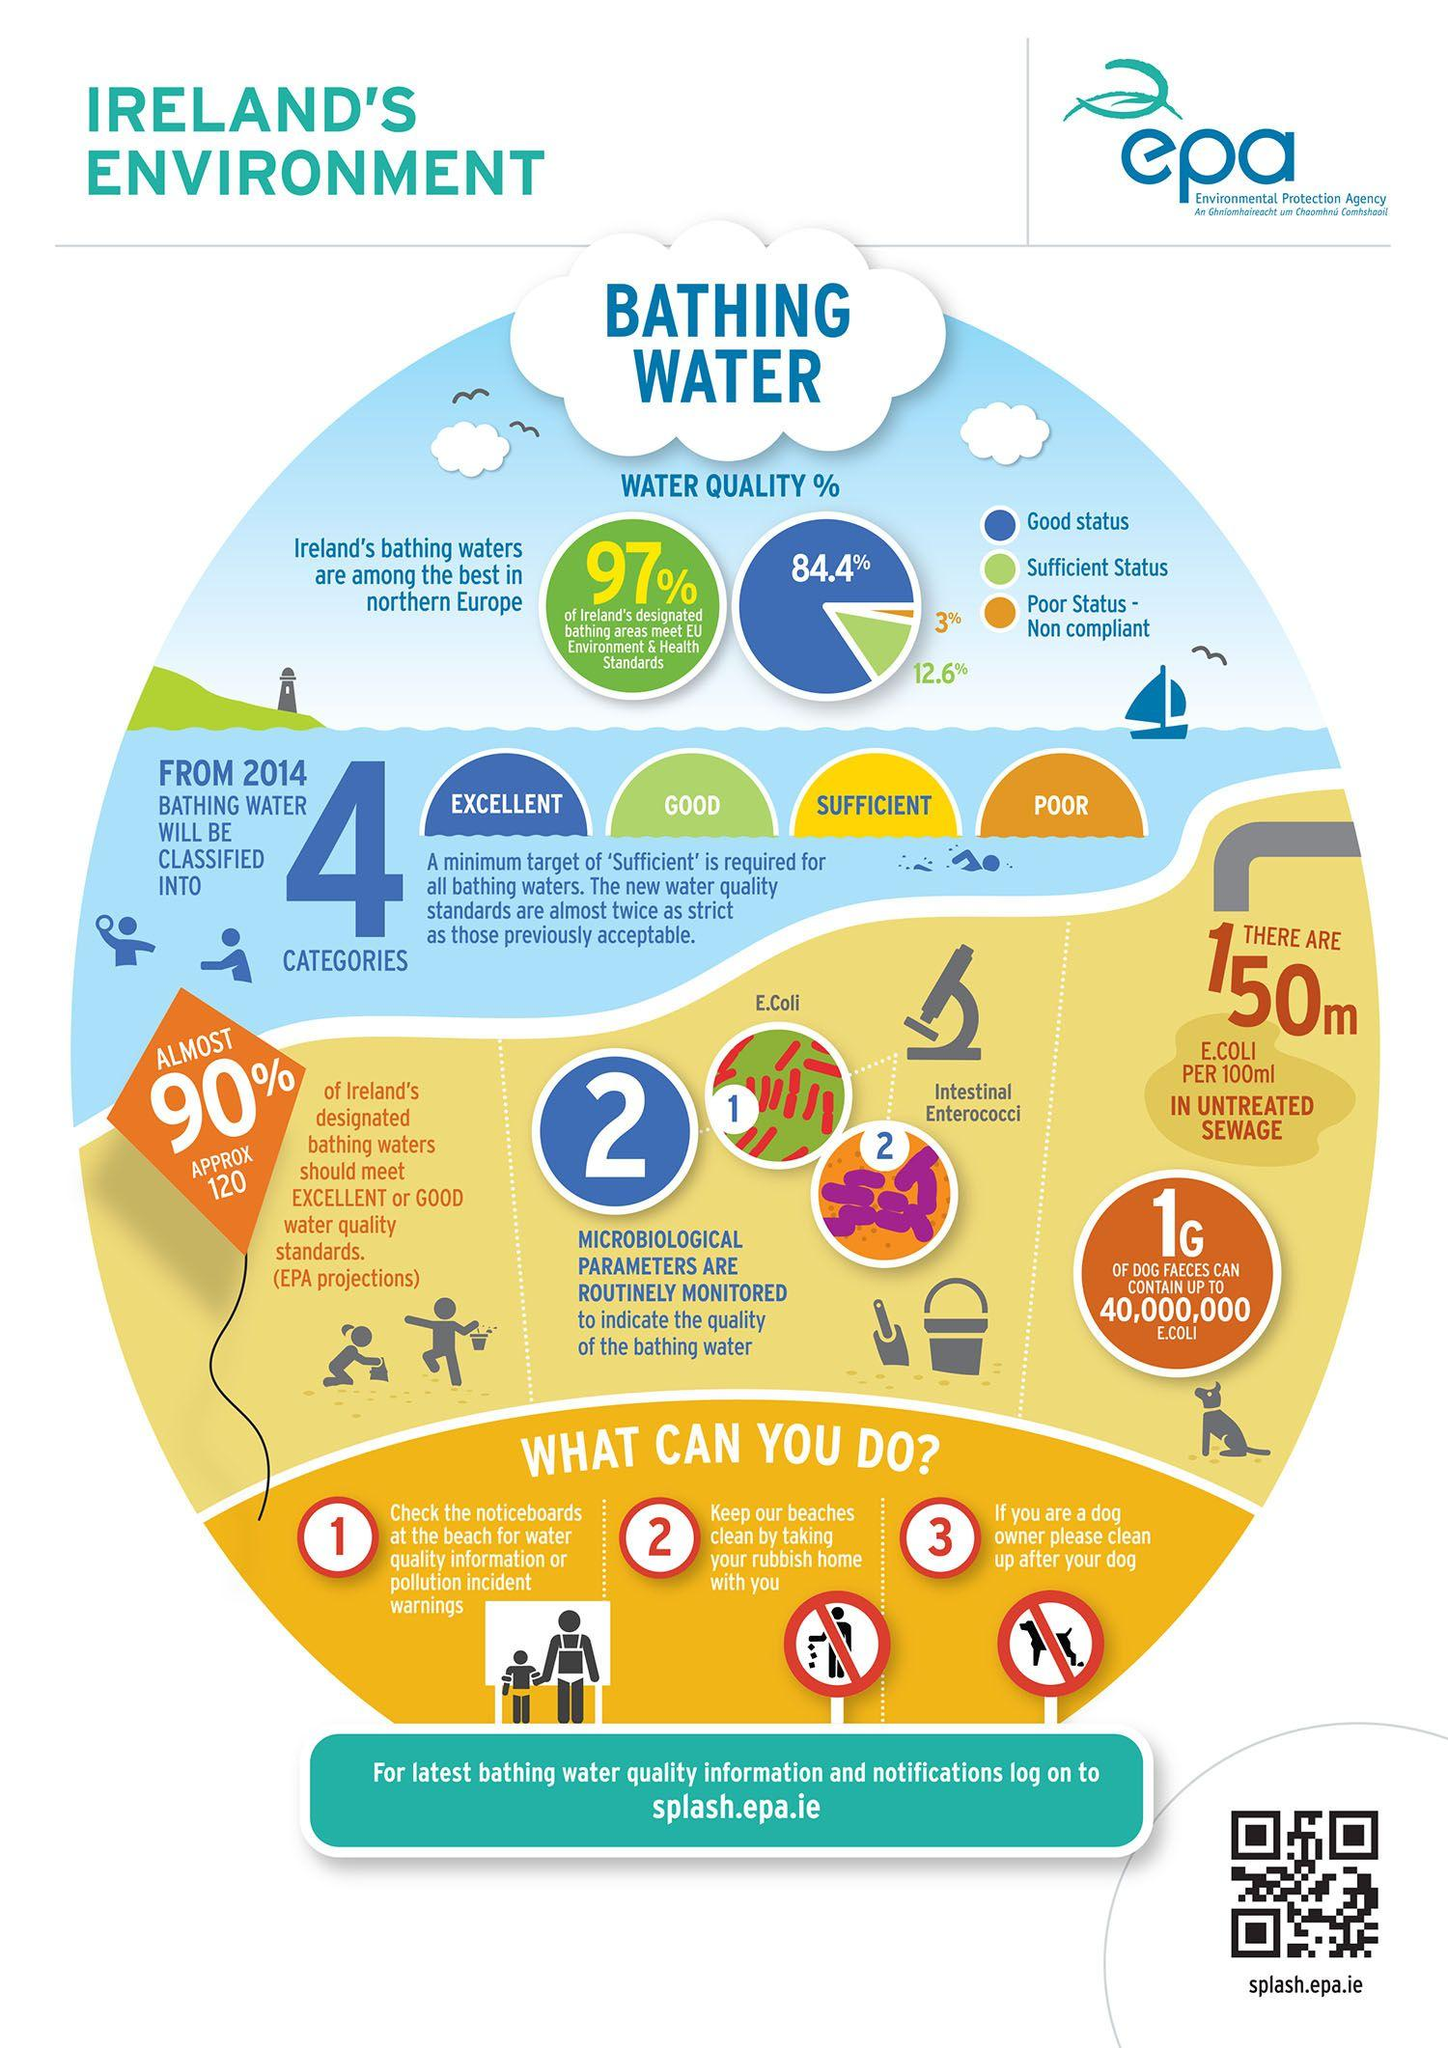Specify some key components in this picture. In Ireland, only 3% of bathing waters meet the poor water quality standard. The two microbiological parameters that are routinely monitored to assess the quality of bathing water are Escherichia coli (E. coli) and Intestinal Enterococci. The amount of E.Coli per 100ml in untreated sewage is 150mg. According to the latest data, 84.4% of Ireland's bathing waters meet the good water quality standard. 